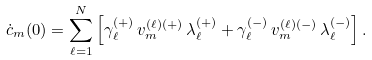Convert formula to latex. <formula><loc_0><loc_0><loc_500><loc_500>\dot { c } _ { m } ( 0 ) = \sum _ { \ell = 1 } ^ { N } \left [ \gamma _ { \ell } ^ { \left ( + \right ) } \, v _ { m } ^ { \left ( \ell \right ) \left ( + \right ) } \, \lambda _ { \ell } ^ { \left ( + \right ) } + \gamma _ { \ell } ^ { \left ( - \right ) } \, v _ { m } ^ { \left ( \ell \right ) \left ( - \right ) } \, \lambda _ { \ell } ^ { \left ( - \right ) } \right ] .</formula> 